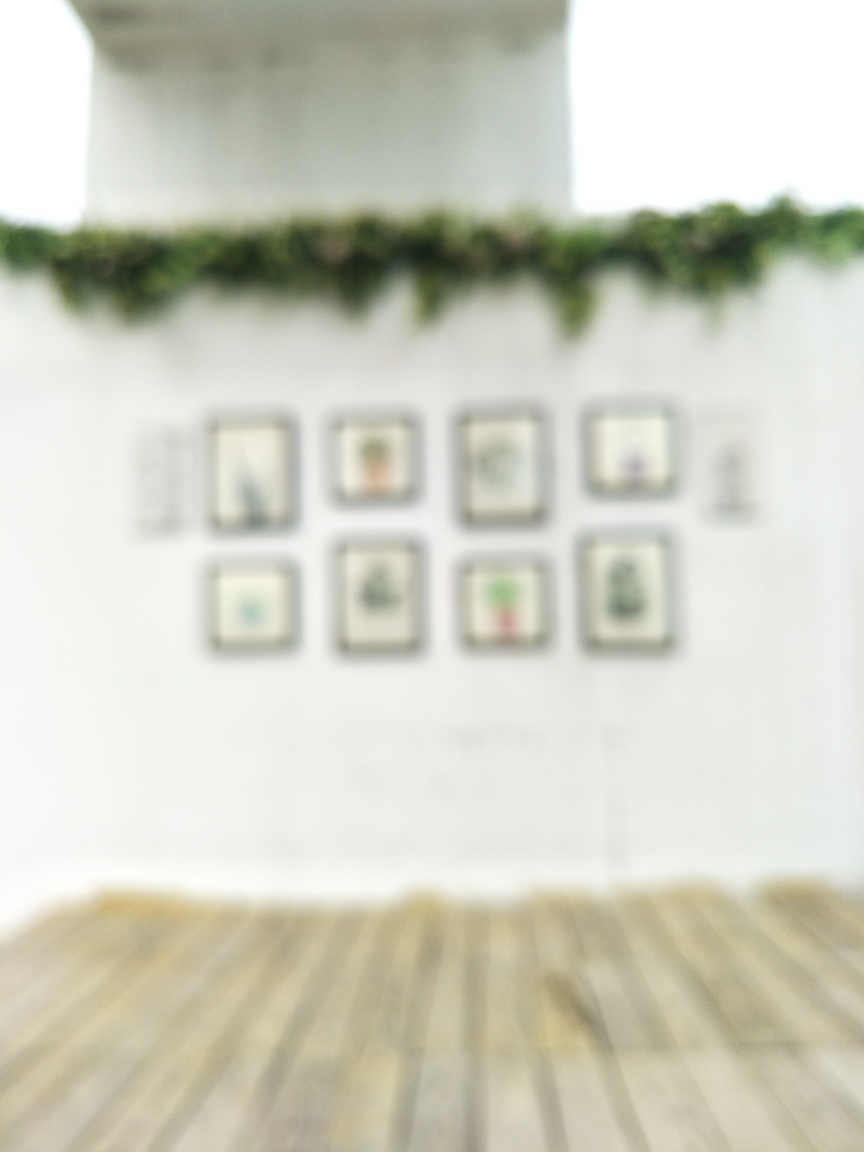Considering we cannot see the details, what might be the reason for a photo like this being taken intentionally? An intentionally blurred photo can be an artistic choice aimed at conveying impressions rather than specifics. The photographer might be exploring themes such as memory, the passage of time, or the subjective nature of perception. This technique encourages viewers to focus more on their emotional response to the composition than on the details of the subject matter. 